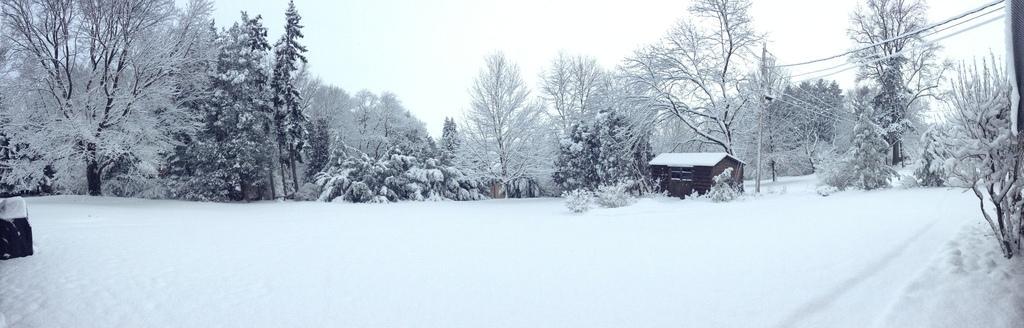Could you give a brief overview of what you see in this image? In this image, on the right side, we can see electric wires and a house which is filled with snow. In the background, we can see some trees which are filled with snow. At the top, we can see a sky, at the bottom, we can see some plants and a snow. 